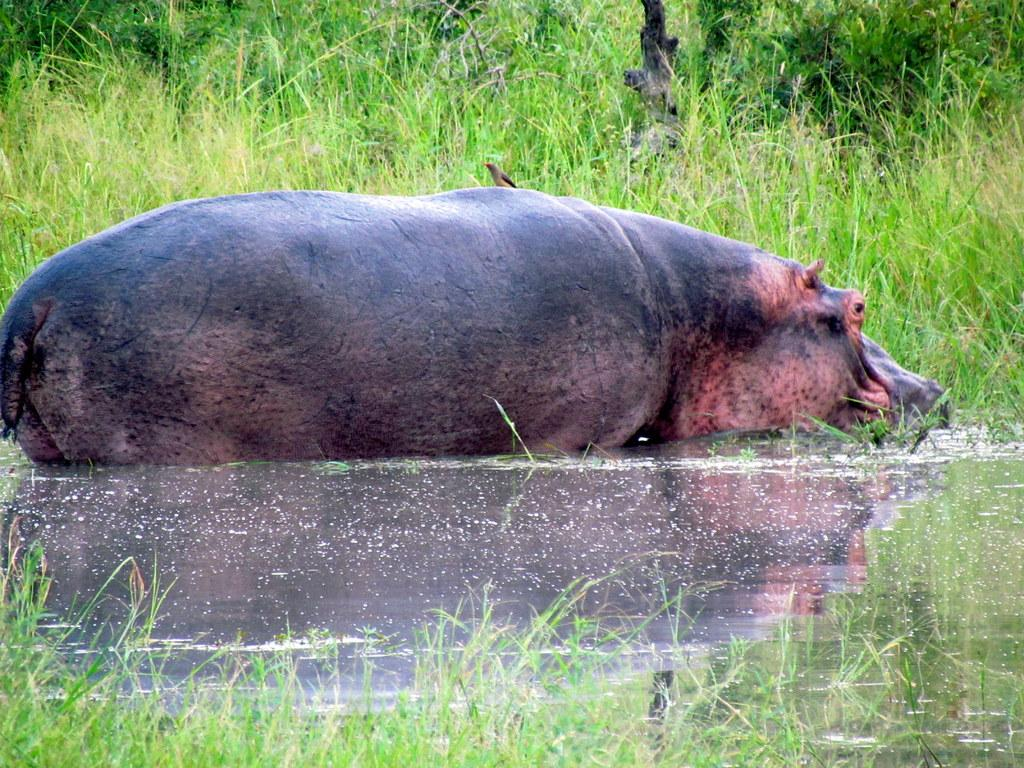What animal is present in the image? There is a bird in the image. What is the bird sitting on? The bird is on a hippopotamus. Where is the hippopotamus located? The hippopotamus is in the water. What type of vegetation can be seen in the image? There is grass visible in the image. What else can be seen in the image besides the bird and hippopotamus? There is a branch in the image. What type of bulb is the bird using to light up the hippopotamus in the image? There is no bulb present in the image, and the bird is not lighting up the hippopotamus. 